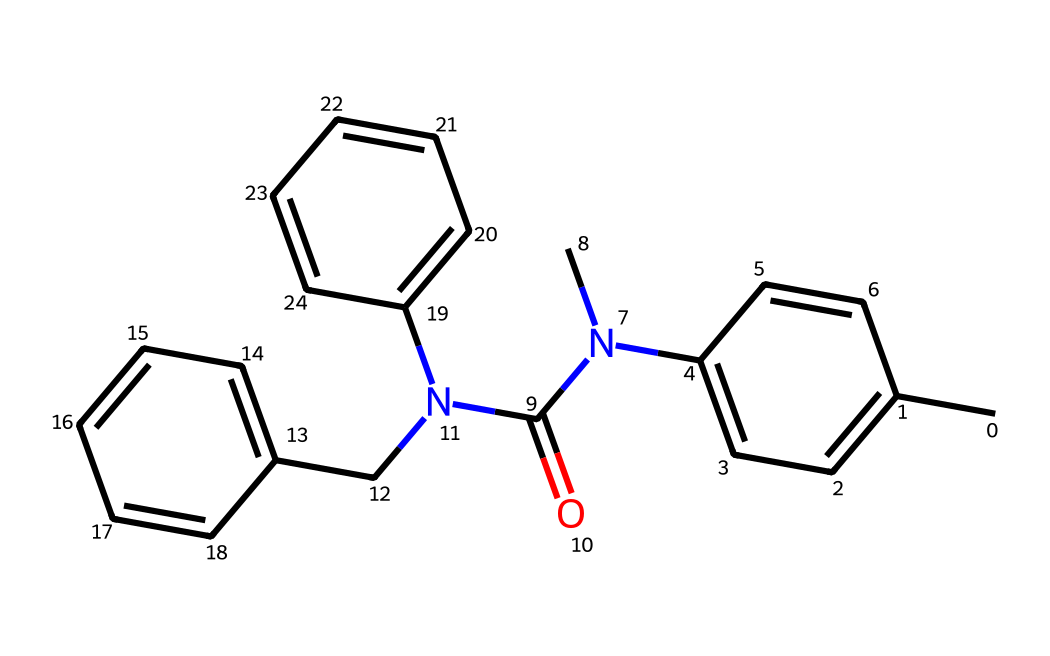What is the primary functional group in this chemical? The structure contains a carbonyl group (C=O) indicated by the carbon atom double-bonded to oxygen, which is characteristic of amides present in the molecule.
Answer: amide How many aromatic rings are present in the structure? The chemical has three distinct aromatic rings, which can be identified by the alternating double bonds and the presence of six-membered carbon rings in the structure.
Answer: three What type of drug class does this chemical belong to? The presence of the nitrogen atom and the specific groupings suggest that this chemical is an antidepressant, commonly found in pharmaceutical applications.
Answer: antidepressant What are the total number of carbon atoms in the molecule? After counting all the carbon atoms present in the structure, I find there are 19 carbon atoms in total based on the SMILES notation.
Answer: nineteen What does the presence of nitrogen in this structure imply about its solubility? The nitrogen in the structure indicates that it may have increased solubility in water relative to non-polar compounds. Nitrogen-containing compounds often have polar characteristics due to the electronegativity of nitrogen.
Answer: increased solubility Which part of the molecule is likely responsible for its biological activity? The nitrogen-containing functional groups, specifically the amide and aromatic rings, are frequently responsible for the biological activity of many pharmaceuticals, influencing binding to biological targets.
Answer: nitrogen-containing groups 